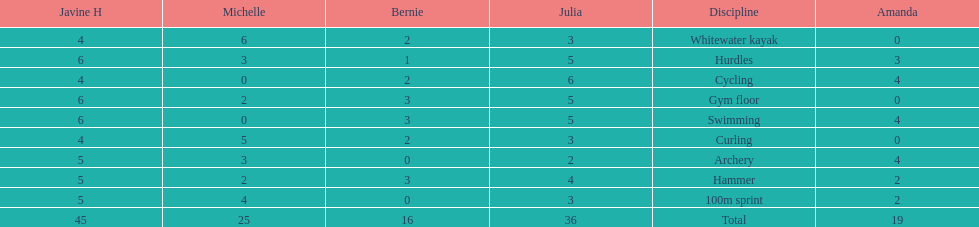What is the last discipline listed on this chart? 100m sprint. 